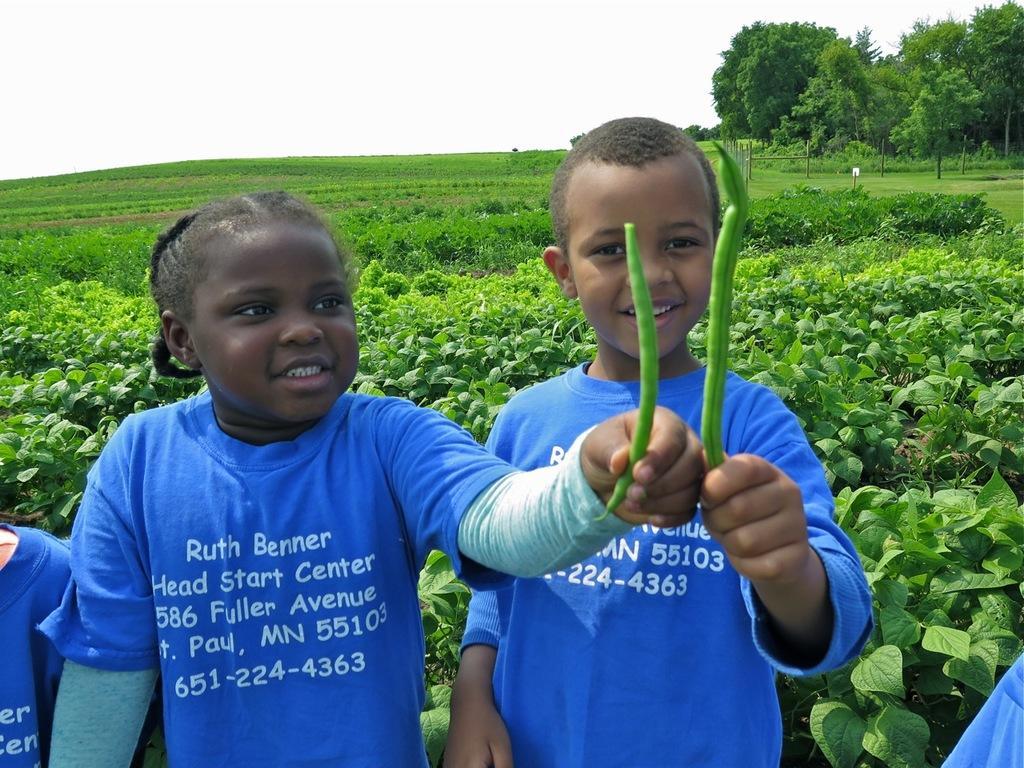How would you summarize this image in a sentence or two? Here we can see two children holding vegetables with their hands. There are plants, grass, and trees. In the background there is sky. 